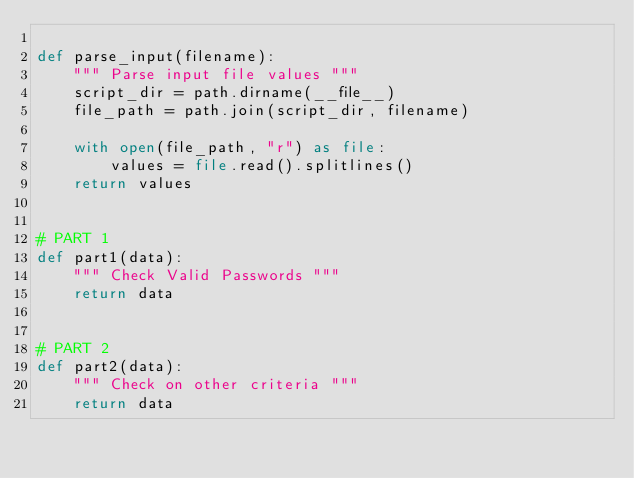<code> <loc_0><loc_0><loc_500><loc_500><_Python_>
def parse_input(filename):
    """ Parse input file values """
    script_dir = path.dirname(__file__)
    file_path = path.join(script_dir, filename)

    with open(file_path, "r") as file:
        values = file.read().splitlines()
    return values


# PART 1
def part1(data):
    """ Check Valid Passwords """
    return data


# PART 2
def part2(data):
    """ Check on other criteria """
    return data
</code> 